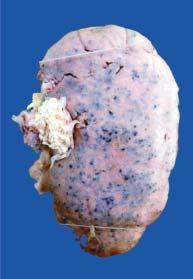what is enlarged in size and weight?
Answer the question using a single word or phrase. Kidney 